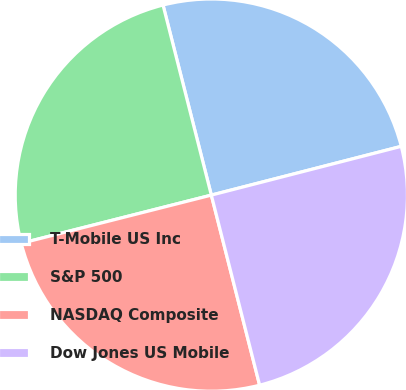<chart> <loc_0><loc_0><loc_500><loc_500><pie_chart><fcel>T-Mobile US Inc<fcel>S&P 500<fcel>NASDAQ Composite<fcel>Dow Jones US Mobile<nl><fcel>24.96%<fcel>24.99%<fcel>25.01%<fcel>25.04%<nl></chart> 